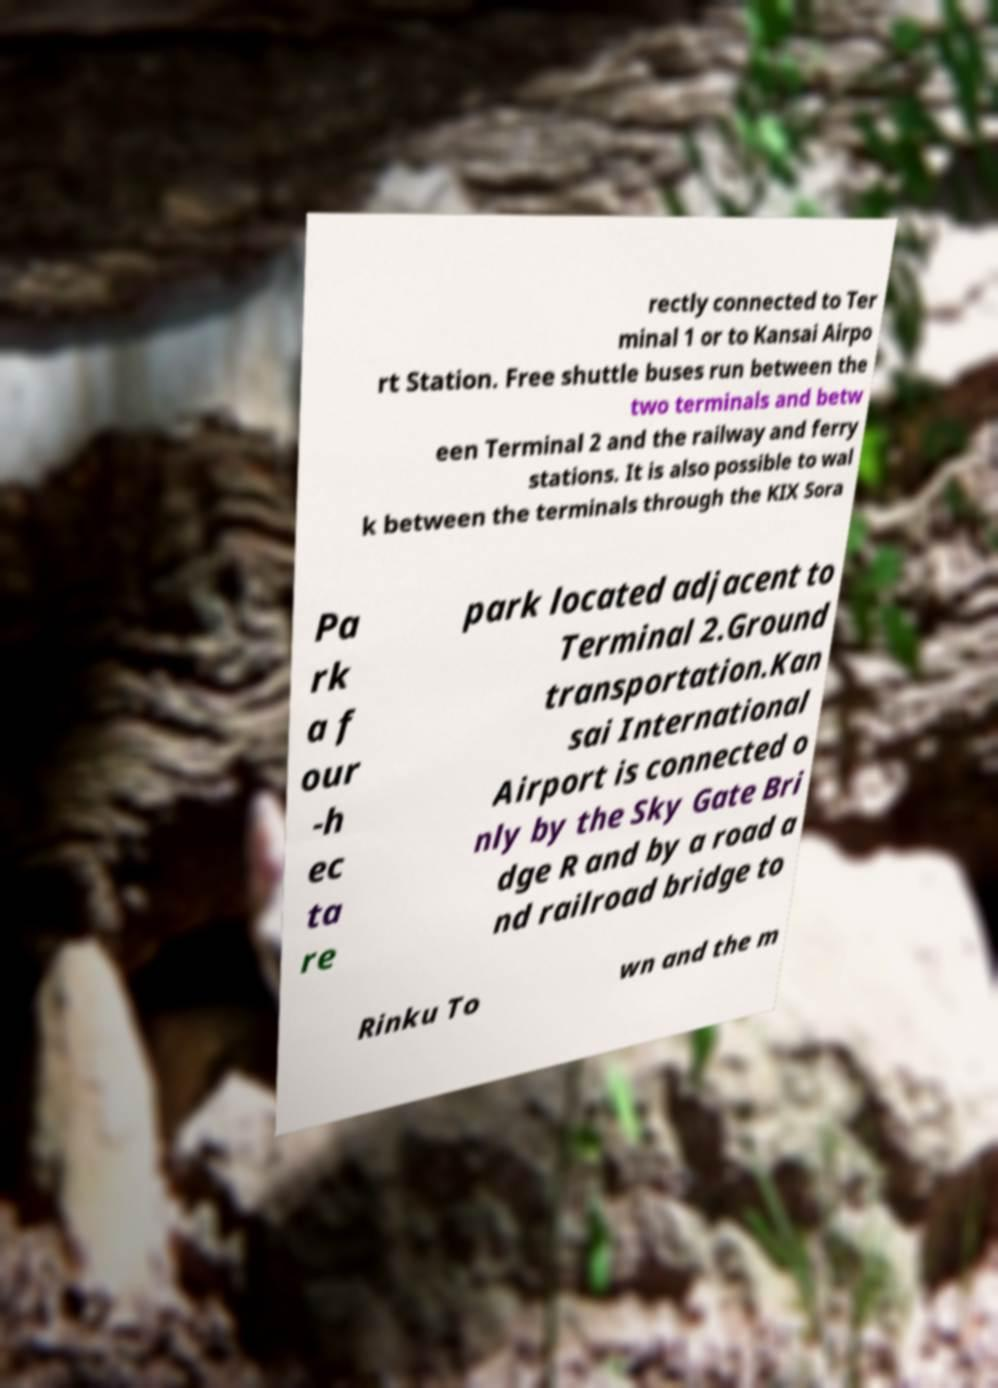Could you assist in decoding the text presented in this image and type it out clearly? rectly connected to Ter minal 1 or to Kansai Airpo rt Station. Free shuttle buses run between the two terminals and betw een Terminal 2 and the railway and ferry stations. It is also possible to wal k between the terminals through the KIX Sora Pa rk a f our -h ec ta re park located adjacent to Terminal 2.Ground transportation.Kan sai International Airport is connected o nly by the Sky Gate Bri dge R and by a road a nd railroad bridge to Rinku To wn and the m 